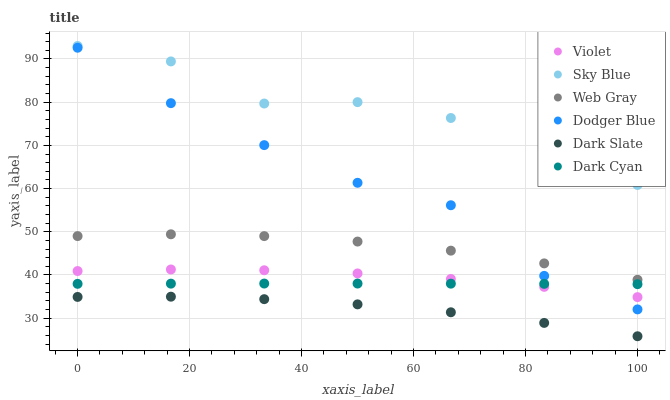Does Dark Slate have the minimum area under the curve?
Answer yes or no. Yes. Does Sky Blue have the maximum area under the curve?
Answer yes or no. Yes. Does Dodger Blue have the minimum area under the curve?
Answer yes or no. No. Does Dodger Blue have the maximum area under the curve?
Answer yes or no. No. Is Dark Cyan the smoothest?
Answer yes or no. Yes. Is Sky Blue the roughest?
Answer yes or no. Yes. Is Dark Slate the smoothest?
Answer yes or no. No. Is Dark Slate the roughest?
Answer yes or no. No. Does Dark Slate have the lowest value?
Answer yes or no. Yes. Does Dodger Blue have the lowest value?
Answer yes or no. No. Does Sky Blue have the highest value?
Answer yes or no. Yes. Does Dodger Blue have the highest value?
Answer yes or no. No. Is Dark Slate less than Dodger Blue?
Answer yes or no. Yes. Is Dark Cyan greater than Dark Slate?
Answer yes or no. Yes. Does Dark Cyan intersect Dodger Blue?
Answer yes or no. Yes. Is Dark Cyan less than Dodger Blue?
Answer yes or no. No. Is Dark Cyan greater than Dodger Blue?
Answer yes or no. No. Does Dark Slate intersect Dodger Blue?
Answer yes or no. No. 